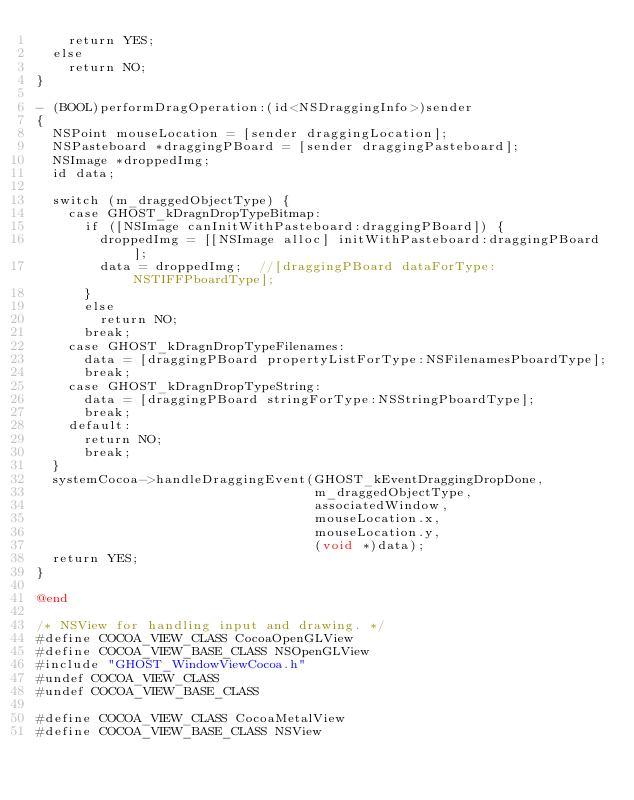<code> <loc_0><loc_0><loc_500><loc_500><_ObjectiveC_>    return YES;
  else
    return NO;
}

- (BOOL)performDragOperation:(id<NSDraggingInfo>)sender
{
  NSPoint mouseLocation = [sender draggingLocation];
  NSPasteboard *draggingPBoard = [sender draggingPasteboard];
  NSImage *droppedImg;
  id data;

  switch (m_draggedObjectType) {
    case GHOST_kDragnDropTypeBitmap:
      if ([NSImage canInitWithPasteboard:draggingPBoard]) {
        droppedImg = [[NSImage alloc] initWithPasteboard:draggingPBoard];
        data = droppedImg;  //[draggingPBoard dataForType:NSTIFFPboardType];
      }
      else
        return NO;
      break;
    case GHOST_kDragnDropTypeFilenames:
      data = [draggingPBoard propertyListForType:NSFilenamesPboardType];
      break;
    case GHOST_kDragnDropTypeString:
      data = [draggingPBoard stringForType:NSStringPboardType];
      break;
    default:
      return NO;
      break;
  }
  systemCocoa->handleDraggingEvent(GHOST_kEventDraggingDropDone,
                                   m_draggedObjectType,
                                   associatedWindow,
                                   mouseLocation.x,
                                   mouseLocation.y,
                                   (void *)data);
  return YES;
}

@end

/* NSView for handling input and drawing. */
#define COCOA_VIEW_CLASS CocoaOpenGLView
#define COCOA_VIEW_BASE_CLASS NSOpenGLView
#include "GHOST_WindowViewCocoa.h"
#undef COCOA_VIEW_CLASS
#undef COCOA_VIEW_BASE_CLASS

#define COCOA_VIEW_CLASS CocoaMetalView
#define COCOA_VIEW_BASE_CLASS NSView</code> 